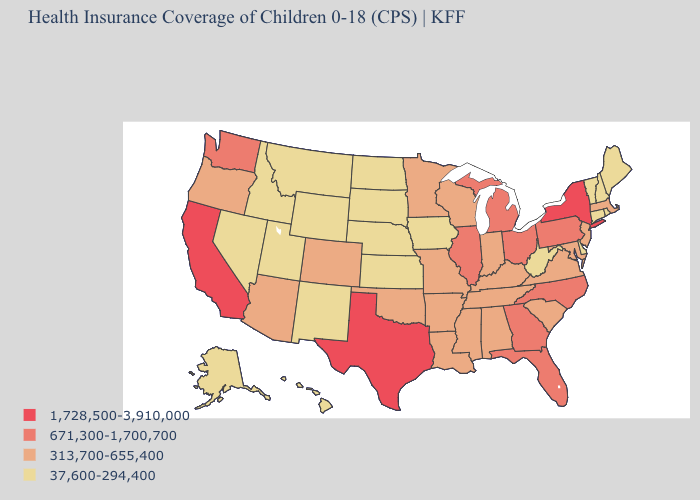Does Florida have the highest value in the South?
Give a very brief answer. No. Which states have the lowest value in the MidWest?
Quick response, please. Iowa, Kansas, Nebraska, North Dakota, South Dakota. What is the value of Virginia?
Quick response, please. 313,700-655,400. Name the states that have a value in the range 671,300-1,700,700?
Concise answer only. Florida, Georgia, Illinois, Michigan, North Carolina, Ohio, Pennsylvania, Washington. What is the value of Illinois?
Quick response, please. 671,300-1,700,700. Name the states that have a value in the range 671,300-1,700,700?
Short answer required. Florida, Georgia, Illinois, Michigan, North Carolina, Ohio, Pennsylvania, Washington. Among the states that border Washington , does Idaho have the highest value?
Give a very brief answer. No. Does New Jersey have the lowest value in the Northeast?
Answer briefly. No. Name the states that have a value in the range 313,700-655,400?
Keep it brief. Alabama, Arizona, Arkansas, Colorado, Indiana, Kentucky, Louisiana, Maryland, Massachusetts, Minnesota, Mississippi, Missouri, New Jersey, Oklahoma, Oregon, South Carolina, Tennessee, Virginia, Wisconsin. Among the states that border Missouri , does Oklahoma have the lowest value?
Short answer required. No. Which states hav the highest value in the Northeast?
Keep it brief. New York. What is the value of Utah?
Short answer required. 37,600-294,400. Which states have the highest value in the USA?
Quick response, please. California, New York, Texas. What is the lowest value in states that border South Carolina?
Keep it brief. 671,300-1,700,700. 